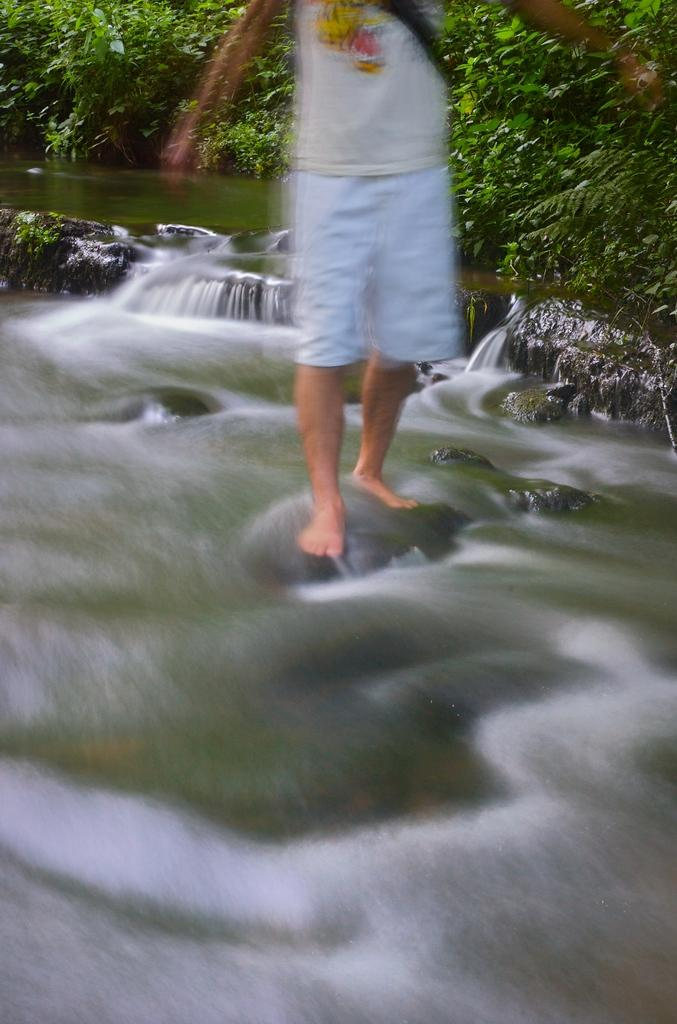What is the person in the image doing? The person is standing on a rock in the image. What can be seen in the foreground of the image? There is water visible in the image. What type of natural environment is depicted in the image? There are many trees in the background of the image, suggesting a forest or wooded area. What type of underwear is the person wearing in the image? There is no information about the person's underwear in the image, so it cannot be determined. 